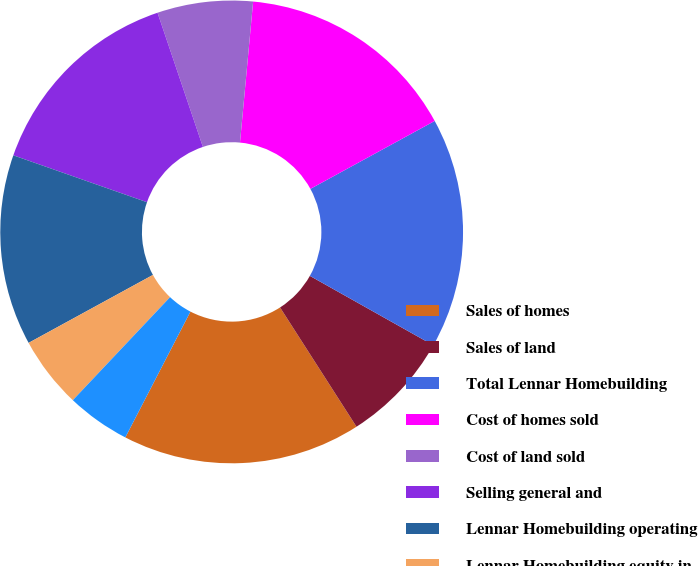Convert chart. <chart><loc_0><loc_0><loc_500><loc_500><pie_chart><fcel>Sales of homes<fcel>Sales of land<fcel>Total Lennar Homebuilding<fcel>Cost of homes sold<fcel>Cost of land sold<fcel>Selling general and<fcel>Lennar Homebuilding operating<fcel>Lennar Homebuilding equity in<fcel>Lennar Homebuilding other<nl><fcel>16.67%<fcel>7.78%<fcel>16.11%<fcel>15.56%<fcel>6.67%<fcel>14.44%<fcel>13.33%<fcel>5.0%<fcel>4.44%<nl></chart> 